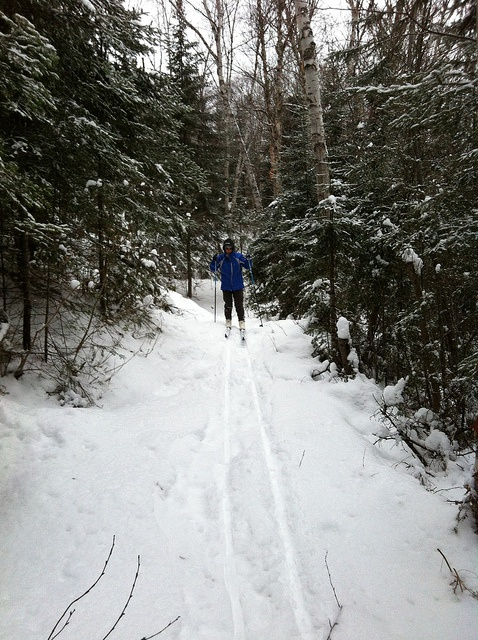Describe the objects in this image and their specific colors. I can see people in black, navy, gray, and darkgray tones and skis in black, lightgray, darkgray, and gray tones in this image. 